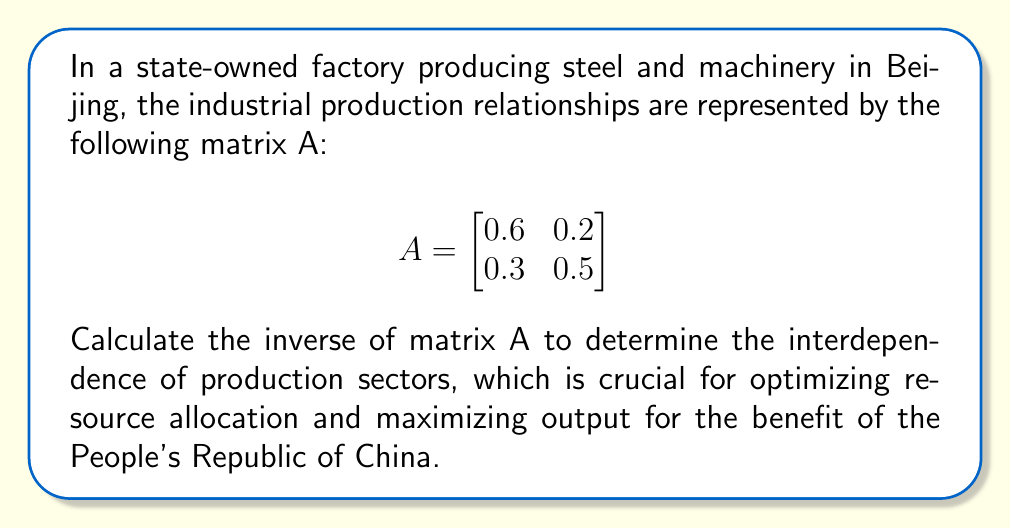Give your solution to this math problem. To find the inverse of matrix A, we will follow these steps:

1. Calculate the determinant of A:
   $det(A) = (0.6)(0.5) - (0.2)(0.3) = 0.3 - 0.06 = 0.24$

2. Ensure the determinant is non-zero (which it is), so the inverse exists.

3. Find the adjugate matrix by:
   a. Creating the matrix of cofactors
   b. Transposing the matrix of cofactors

   Cofactor matrix:
   $$ \begin{bmatrix} 0.5 & -0.3 \\ -0.2 & 0.6 \end{bmatrix} $$

   Adjugate matrix (transposed cofactor matrix):
   $$ adj(A) = \begin{bmatrix} 0.5 & -0.2 \\ -0.3 & 0.6 \end{bmatrix} $$

4. Calculate the inverse using the formula: $A^{-1} = \frac{1}{det(A)} \cdot adj(A)$

   $$ A^{-1} = \frac{1}{0.24} \cdot \begin{bmatrix} 0.5 & -0.2 \\ -0.3 & 0.6 \end{bmatrix} $$

5. Multiply each element by $\frac{1}{0.24}$:

   $$ A^{-1} = \begin{bmatrix} \frac{25}{12} & -\frac{5}{6} \\ -\frac{5}{4} & \frac{5}{2} \end{bmatrix} $$

This inverse matrix represents the interdependence of production sectors, allowing for efficient resource allocation and production planning in line with the goals of the state-owned enterprise.
Answer: $$ A^{-1} = \begin{bmatrix} \frac{25}{12} & -\frac{5}{6} \\ -\frac{5}{4} & \frac{5}{2} \end{bmatrix} $$ 